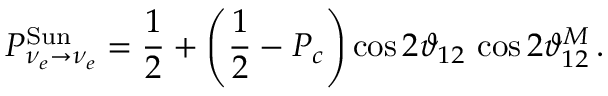Convert formula to latex. <formula><loc_0><loc_0><loc_500><loc_500>P _ { \nu _ { e } \to \nu _ { e } } ^ { S u n } = \frac { 1 } { 2 } + \left ( \frac { 1 } { 2 } - P _ { c } \right ) \cos { 2 \vartheta _ { 1 2 } } \, \cos { 2 \vartheta _ { 1 2 } ^ { M } } \, .</formula> 